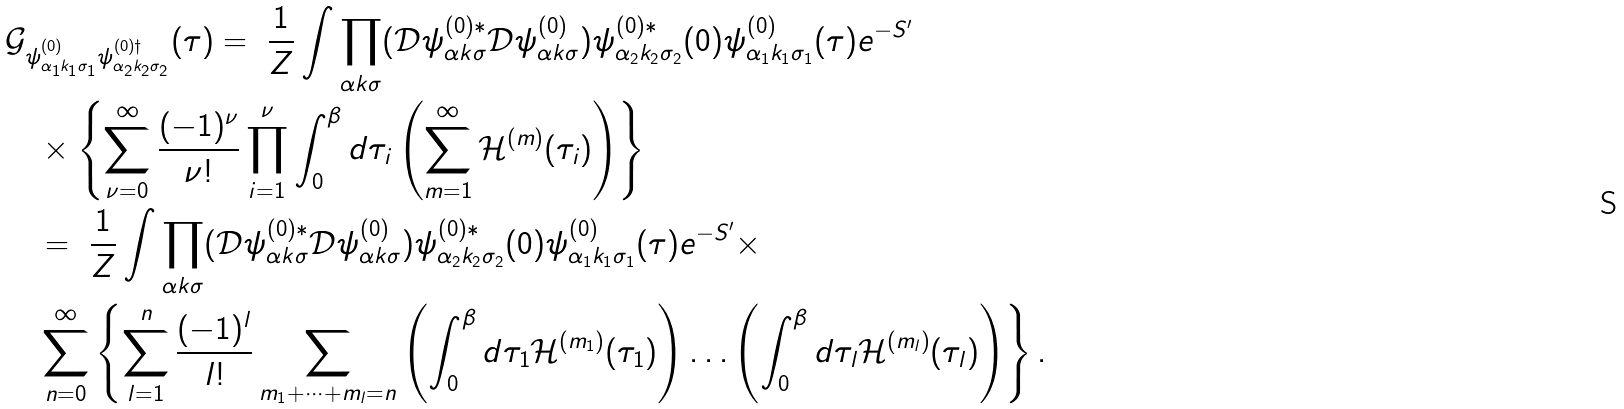Convert formula to latex. <formula><loc_0><loc_0><loc_500><loc_500>& \mathcal { G } _ { \psi ^ { ( 0 ) } _ { \alpha _ { 1 } k _ { 1 } \sigma _ { 1 } } \psi ^ { ( 0 ) \dag } _ { \alpha _ { 2 } k _ { 2 } \sigma _ { 2 } } } ( \tau ) = \ \frac { 1 } { Z } \int \prod _ { \alpha k \sigma } ( \mathcal { D } \psi ^ { ( 0 ) \ast } _ { \alpha k \sigma } \mathcal { D } \psi ^ { ( 0 ) } _ { \alpha k \sigma } ) \psi ^ { ( 0 ) \ast } _ { \alpha _ { 2 } k _ { 2 } \sigma _ { 2 } } ( 0 ) \psi ^ { ( 0 ) } _ { \alpha _ { 1 } k _ { 1 } \sigma _ { 1 } } ( \tau ) e ^ { - S ^ { \prime } } \\ & \quad \times \left \{ \sum _ { \nu = 0 } ^ { \infty } \frac { ( - 1 ) ^ { \nu } } { \nu ! } \prod _ { i = 1 } ^ { \nu } \int _ { 0 } ^ { \beta } d \tau _ { i } \left ( \sum _ { m = 1 } ^ { \infty } \mathcal { H } ^ { ( m ) } ( \tau _ { i } ) \right ) \right \} \\ & \quad = \ \frac { 1 } { Z } \int \prod _ { \alpha k \sigma } ( \mathcal { D } \psi ^ { ( 0 ) \ast } _ { \alpha k \sigma } \mathcal { D } \psi ^ { ( 0 ) } _ { \alpha k \sigma } ) \psi ^ { ( 0 ) \ast } _ { \alpha _ { 2 } k _ { 2 } \sigma _ { 2 } } ( 0 ) \psi ^ { ( 0 ) } _ { \alpha _ { 1 } k _ { 1 } \sigma _ { 1 } } ( \tau ) e ^ { - S ^ { \prime } } \times \\ & \quad \sum _ { n = 0 } ^ { \infty } \left \{ \sum _ { l = 1 } ^ { n } \frac { ( - 1 ) ^ { l } } { l ! } \sum _ { m _ { 1 } + \dots + m _ { l } = n } \left ( \int _ { 0 } ^ { \beta } d \tau _ { 1 } \mathcal { H } ^ { ( m _ { 1 } ) } ( \tau _ { 1 } ) \right ) \dots \left ( \int _ { 0 } ^ { \beta } d \tau _ { l } \mathcal { H } ^ { ( m _ { l } ) } ( \tau _ { l } ) \right ) \right \} .</formula> 